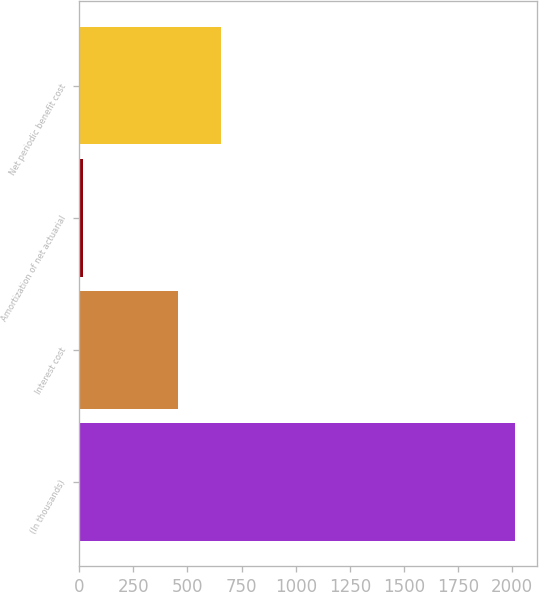<chart> <loc_0><loc_0><loc_500><loc_500><bar_chart><fcel>(In thousands)<fcel>Interest cost<fcel>Amortization of net actuarial<fcel>Net periodic benefit cost<nl><fcel>2014<fcel>454<fcel>19<fcel>653.5<nl></chart> 